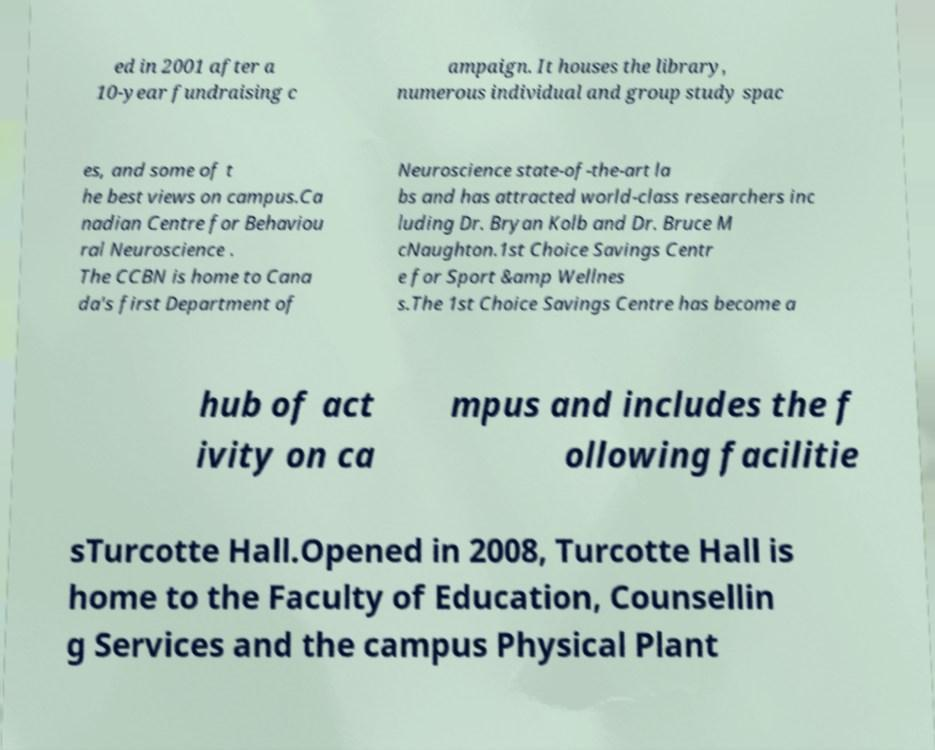Can you accurately transcribe the text from the provided image for me? ed in 2001 after a 10-year fundraising c ampaign. It houses the library, numerous individual and group study spac es, and some of t he best views on campus.Ca nadian Centre for Behaviou ral Neuroscience . The CCBN is home to Cana da's first Department of Neuroscience state-of-the-art la bs and has attracted world-class researchers inc luding Dr. Bryan Kolb and Dr. Bruce M cNaughton.1st Choice Savings Centr e for Sport &amp Wellnes s.The 1st Choice Savings Centre has become a hub of act ivity on ca mpus and includes the f ollowing facilitie sTurcotte Hall.Opened in 2008, Turcotte Hall is home to the Faculty of Education, Counsellin g Services and the campus Physical Plant 